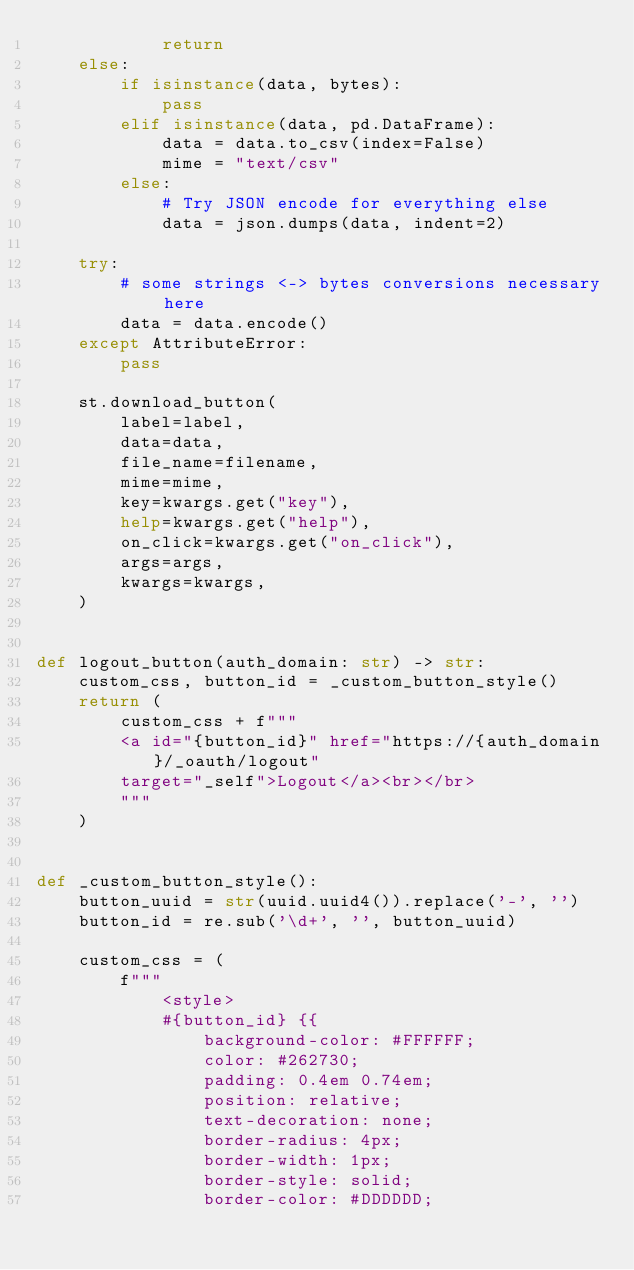<code> <loc_0><loc_0><loc_500><loc_500><_Python_>            return
    else:
        if isinstance(data, bytes):
            pass
        elif isinstance(data, pd.DataFrame):
            data = data.to_csv(index=False)
            mime = "text/csv"
        else:
            # Try JSON encode for everything else
            data = json.dumps(data, indent=2)

    try:
        # some strings <-> bytes conversions necessary here
        data = data.encode()
    except AttributeError:
        pass

    st.download_button(
        label=label,
        data=data,
        file_name=filename,
        mime=mime,
        key=kwargs.get("key"),
        help=kwargs.get("help"),
        on_click=kwargs.get("on_click"),
        args=args,
        kwargs=kwargs,
    )


def logout_button(auth_domain: str) -> str:
    custom_css, button_id = _custom_button_style()
    return (
        custom_css + f"""
        <a id="{button_id}" href="https://{auth_domain}/_oauth/logout" 
        target="_self">Logout</a><br></br>
        """
    )


def _custom_button_style():
    button_uuid = str(uuid.uuid4()).replace('-', '')
    button_id = re.sub('\d+', '', button_uuid)

    custom_css = (
        f"""
            <style>
            #{button_id} {{
                background-color: #FFFFFF;
                color: #262730;
                padding: 0.4em 0.74em;
                position: relative;
                text-decoration: none;
                border-radius: 4px;
                border-width: 1px;
                border-style: solid;
                border-color: #DDDDDD;</code> 